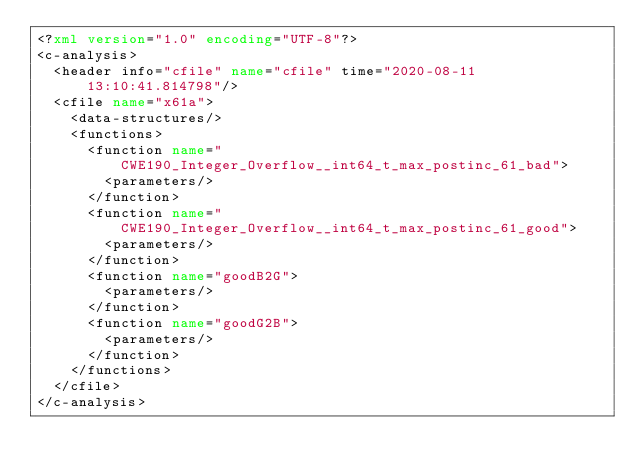<code> <loc_0><loc_0><loc_500><loc_500><_XML_><?xml version="1.0" encoding="UTF-8"?>
<c-analysis>
  <header info="cfile" name="cfile" time="2020-08-11 13:10:41.814798"/>
  <cfile name="x61a">
    <data-structures/>
    <functions>
      <function name="CWE190_Integer_Overflow__int64_t_max_postinc_61_bad">
        <parameters/>
      </function>
      <function name="CWE190_Integer_Overflow__int64_t_max_postinc_61_good">
        <parameters/>
      </function>
      <function name="goodB2G">
        <parameters/>
      </function>
      <function name="goodG2B">
        <parameters/>
      </function>
    </functions>
  </cfile>
</c-analysis>
</code> 